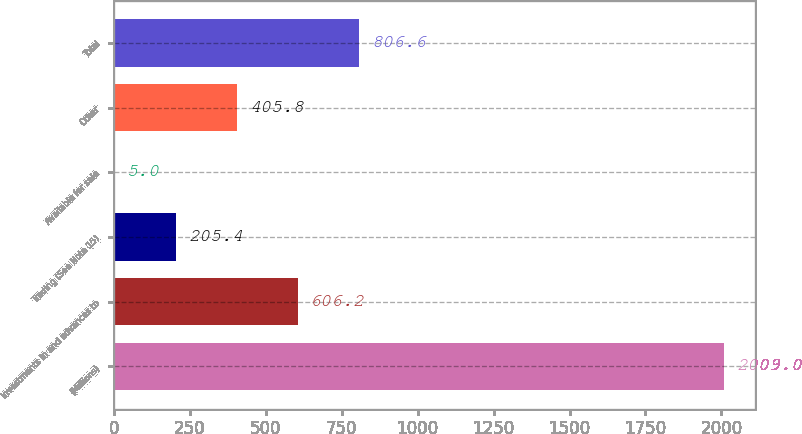Convert chart. <chart><loc_0><loc_0><loc_500><loc_500><bar_chart><fcel>(Millions)<fcel>Investments in and advances to<fcel>Trading (See Note 15)<fcel>Available for sale<fcel>Other<fcel>Total<nl><fcel>2009<fcel>606.2<fcel>205.4<fcel>5<fcel>405.8<fcel>806.6<nl></chart> 